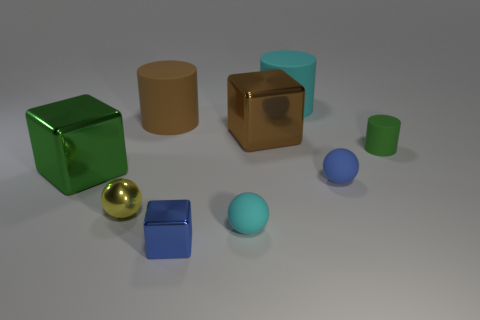Subtract all small yellow shiny balls. How many balls are left? 2 Add 1 red metal spheres. How many objects exist? 10 Subtract all blue cubes. How many cubes are left? 2 Subtract all cylinders. How many objects are left? 6 Subtract 3 cubes. How many cubes are left? 0 Subtract 0 cyan cubes. How many objects are left? 9 Subtract all blue spheres. Subtract all blue blocks. How many spheres are left? 2 Subtract all matte spheres. Subtract all metal things. How many objects are left? 3 Add 3 big cyan rubber cylinders. How many big cyan rubber cylinders are left? 4 Add 8 large metal cubes. How many large metal cubes exist? 10 